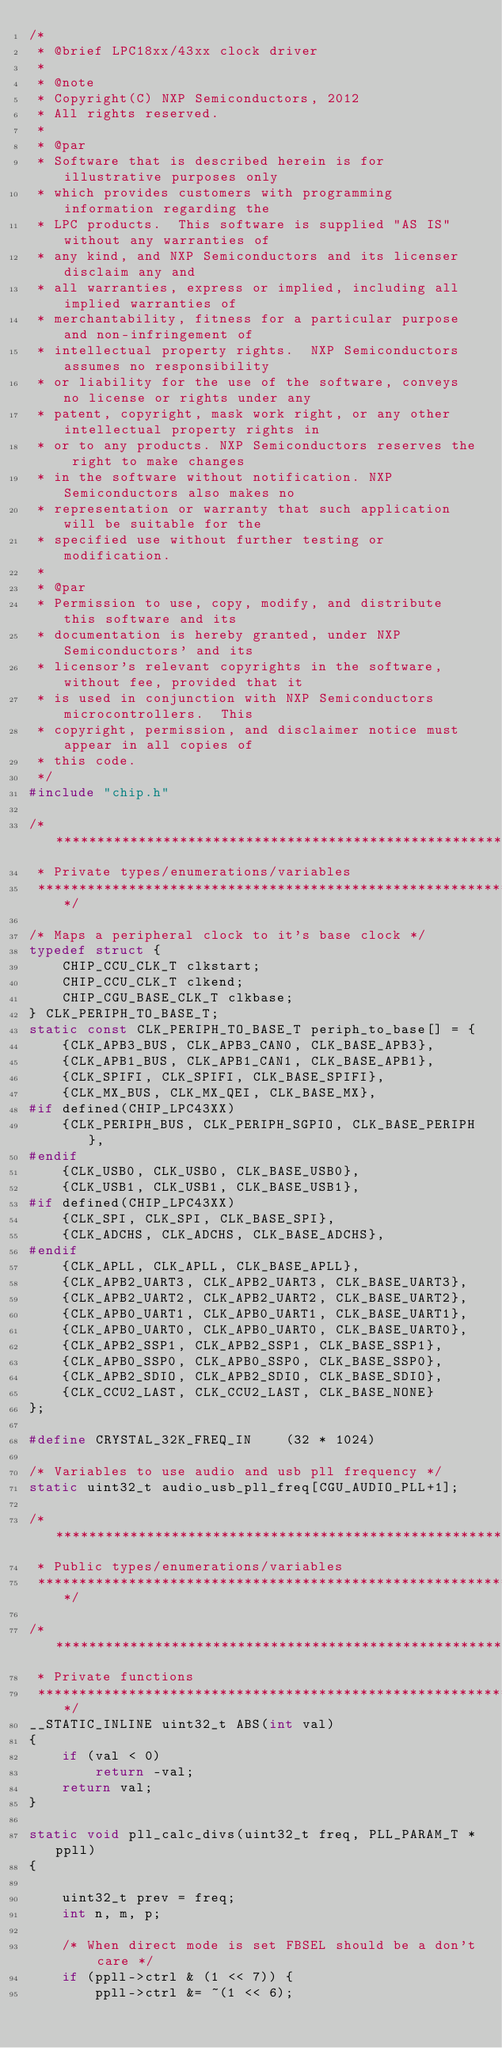Convert code to text. <code><loc_0><loc_0><loc_500><loc_500><_C_>/*
 * @brief LPC18xx/43xx clock driver
 *
 * @note
 * Copyright(C) NXP Semiconductors, 2012
 * All rights reserved.
 *
 * @par
 * Software that is described herein is for illustrative purposes only
 * which provides customers with programming information regarding the
 * LPC products.  This software is supplied "AS IS" without any warranties of
 * any kind, and NXP Semiconductors and its licenser disclaim any and
 * all warranties, express or implied, including all implied warranties of
 * merchantability, fitness for a particular purpose and non-infringement of
 * intellectual property rights.  NXP Semiconductors assumes no responsibility
 * or liability for the use of the software, conveys no license or rights under any
 * patent, copyright, mask work right, or any other intellectual property rights in
 * or to any products. NXP Semiconductors reserves the right to make changes
 * in the software without notification. NXP Semiconductors also makes no
 * representation or warranty that such application will be suitable for the
 * specified use without further testing or modification.
 *
 * @par
 * Permission to use, copy, modify, and distribute this software and its
 * documentation is hereby granted, under NXP Semiconductors' and its
 * licensor's relevant copyrights in the software, without fee, provided that it
 * is used in conjunction with NXP Semiconductors microcontrollers.  This
 * copyright, permission, and disclaimer notice must appear in all copies of
 * this code.
 */
#include "chip.h"

/*****************************************************************************
 * Private types/enumerations/variables
 ****************************************************************************/

/* Maps a peripheral clock to it's base clock */
typedef struct {
	CHIP_CCU_CLK_T clkstart;
	CHIP_CCU_CLK_T clkend;
	CHIP_CGU_BASE_CLK_T clkbase;
} CLK_PERIPH_TO_BASE_T;
static const CLK_PERIPH_TO_BASE_T periph_to_base[] = {
	{CLK_APB3_BUS, CLK_APB3_CAN0, CLK_BASE_APB3},
	{CLK_APB1_BUS, CLK_APB1_CAN1, CLK_BASE_APB1},
	{CLK_SPIFI, CLK_SPIFI, CLK_BASE_SPIFI},
	{CLK_MX_BUS, CLK_MX_QEI, CLK_BASE_MX},
#if defined(CHIP_LPC43XX)
	{CLK_PERIPH_BUS, CLK_PERIPH_SGPIO, CLK_BASE_PERIPH},
#endif
	{CLK_USB0, CLK_USB0, CLK_BASE_USB0},
	{CLK_USB1, CLK_USB1, CLK_BASE_USB1},
#if defined(CHIP_LPC43XX)
	{CLK_SPI, CLK_SPI, CLK_BASE_SPI},
	{CLK_ADCHS, CLK_ADCHS, CLK_BASE_ADCHS},
#endif
	{CLK_APLL, CLK_APLL, CLK_BASE_APLL},
	{CLK_APB2_UART3, CLK_APB2_UART3, CLK_BASE_UART3},
	{CLK_APB2_UART2, CLK_APB2_UART2, CLK_BASE_UART2},
	{CLK_APB0_UART1, CLK_APB0_UART1, CLK_BASE_UART1},
	{CLK_APB0_UART0, CLK_APB0_UART0, CLK_BASE_UART0},
	{CLK_APB2_SSP1, CLK_APB2_SSP1, CLK_BASE_SSP1},
	{CLK_APB0_SSP0, CLK_APB0_SSP0, CLK_BASE_SSP0},
	{CLK_APB2_SDIO, CLK_APB2_SDIO, CLK_BASE_SDIO},
	{CLK_CCU2_LAST, CLK_CCU2_LAST, CLK_BASE_NONE}
};

#define CRYSTAL_32K_FREQ_IN    (32 * 1024)

/* Variables to use audio and usb pll frequency */
static uint32_t audio_usb_pll_freq[CGU_AUDIO_PLL+1];

/*****************************************************************************
 * Public types/enumerations/variables
 ****************************************************************************/

/*****************************************************************************
 * Private functions
 ****************************************************************************/
__STATIC_INLINE uint32_t ABS(int val)
{
	if (val < 0)
		return -val;
	return val;
}

static void pll_calc_divs(uint32_t freq, PLL_PARAM_T *ppll)
{

	uint32_t prev = freq;
	int n, m, p;

	/* When direct mode is set FBSEL should be a don't care */
	if (ppll->ctrl & (1 << 7)) {
		ppll->ctrl &= ~(1 << 6);</code> 